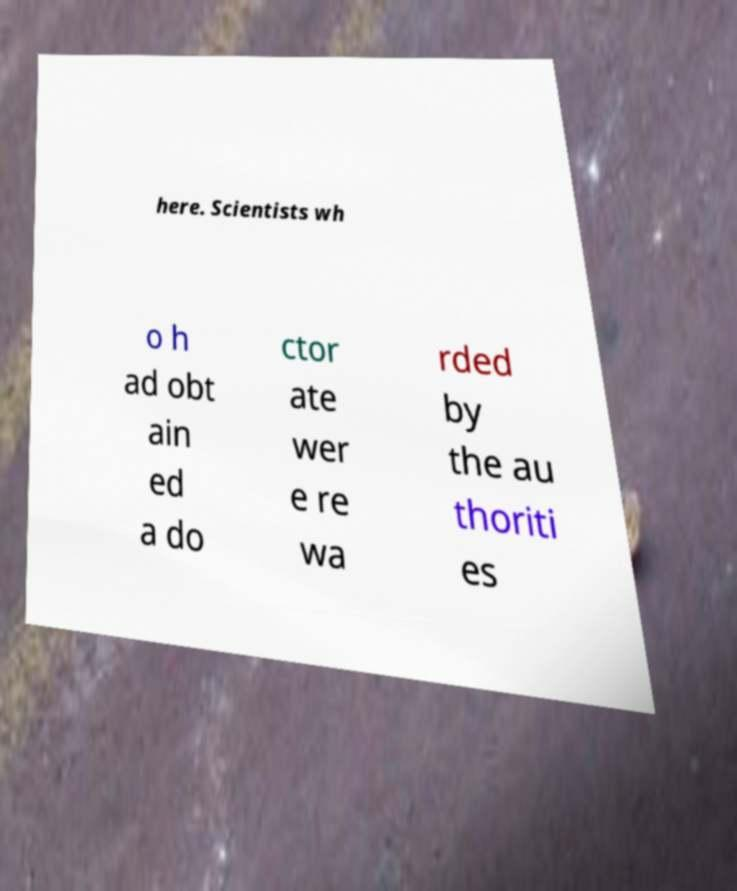For documentation purposes, I need the text within this image transcribed. Could you provide that? here. Scientists wh o h ad obt ain ed a do ctor ate wer e re wa rded by the au thoriti es 